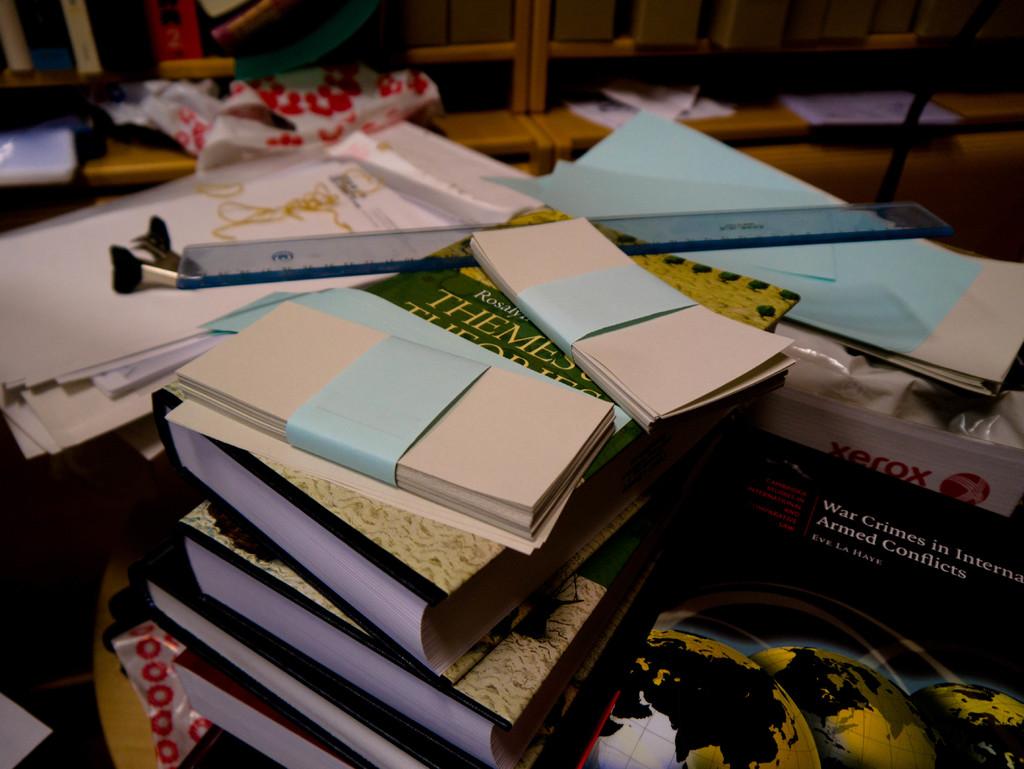What brand is the white box?
Make the answer very short. Xerox. 